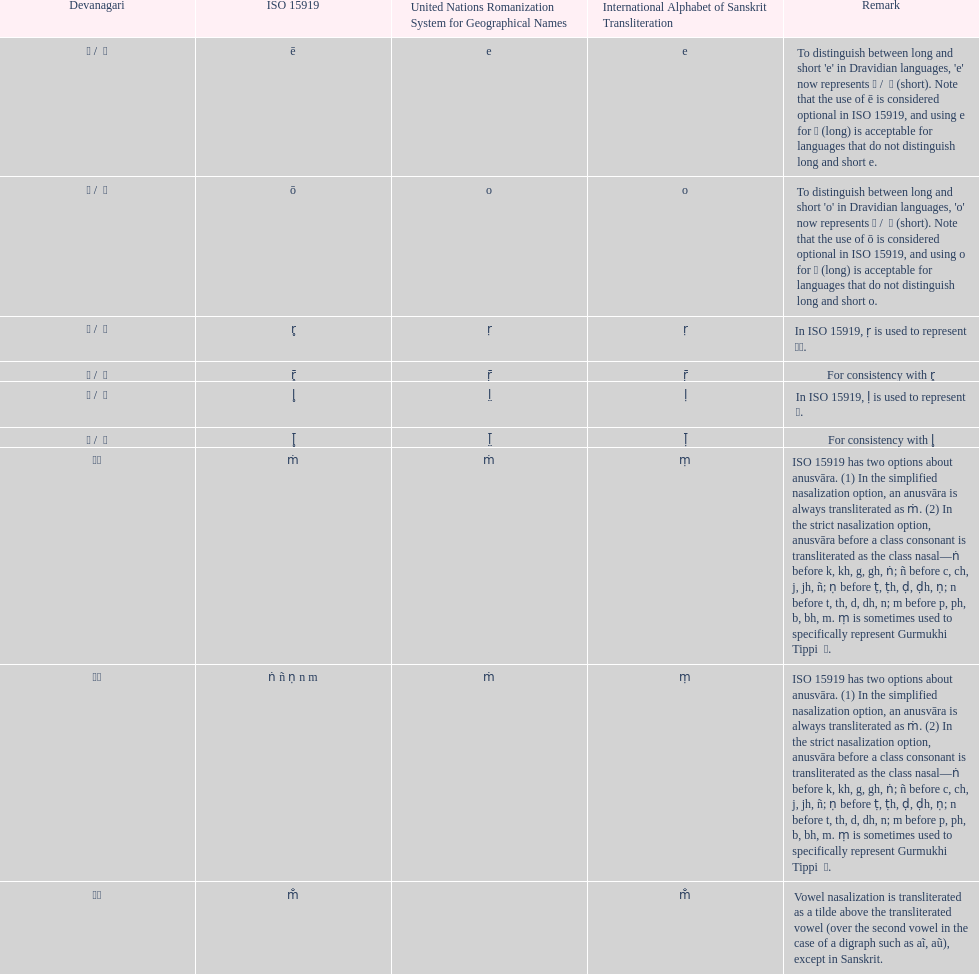Can you parse all the data within this table? {'header': ['Devanagari', 'ISO 15919', 'United Nations Romanization System for Geographical Names', 'International Alphabet of Sanskrit Transliteration', 'Remark'], 'rows': [['ए / \xa0े', 'ē', 'e', 'e', "To distinguish between long and short 'e' in Dravidian languages, 'e' now represents ऎ / \xa0ॆ (short). Note that the use of ē is considered optional in ISO 15919, and using e for ए (long) is acceptable for languages that do not distinguish long and short e."], ['ओ / \xa0ो', 'ō', 'o', 'o', "To distinguish between long and short 'o' in Dravidian languages, 'o' now represents ऒ / \xa0ॊ (short). Note that the use of ō is considered optional in ISO 15919, and using o for ओ (long) is acceptable for languages that do not distinguish long and short o."], ['ऋ / \xa0ृ', 'r̥', 'ṛ', 'ṛ', 'In ISO 15919, ṛ is used to represent ड़.'], ['ॠ / \xa0ॄ', 'r̥̄', 'ṝ', 'ṝ', 'For consistency with r̥'], ['ऌ / \xa0ॢ', 'l̥', 'l̤', 'ḷ', 'In ISO 15919, ḷ is used to represent ळ.'], ['ॡ / \xa0ॣ', 'l̥̄', 'l̤̄', 'ḹ', 'For consistency with l̥'], ['◌ं', 'ṁ', 'ṁ', 'ṃ', 'ISO 15919 has two options about anusvāra. (1) In the simplified nasalization option, an anusvāra is always transliterated as ṁ. (2) In the strict nasalization option, anusvāra before a class consonant is transliterated as the class nasal—ṅ before k, kh, g, gh, ṅ; ñ before c, ch, j, jh, ñ; ṇ before ṭ, ṭh, ḍ, ḍh, ṇ; n before t, th, d, dh, n; m before p, ph, b, bh, m. ṃ is sometimes used to specifically represent Gurmukhi Tippi \xa0ੰ.'], ['◌ं', 'ṅ ñ ṇ n m', 'ṁ', 'ṃ', 'ISO 15919 has two options about anusvāra. (1) In the simplified nasalization option, an anusvāra is always transliterated as ṁ. (2) In the strict nasalization option, anusvāra before a class consonant is transliterated as the class nasal—ṅ before k, kh, g, gh, ṅ; ñ before c, ch, j, jh, ñ; ṇ before ṭ, ṭh, ḍ, ḍh, ṇ; n before t, th, d, dh, n; m before p, ph, b, bh, m. ṃ is sometimes used to specifically represent Gurmukhi Tippi \xa0ੰ.'], ['◌ँ', 'm̐', '', 'm̐', 'Vowel nasalization is transliterated as a tilde above the transliterated vowel (over the second vowel in the case of a digraph such as aĩ, aũ), except in Sanskrit.']]} What is the total number of translations? 8. 